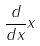<formula> <loc_0><loc_0><loc_500><loc_500>\frac { d } { d x } x</formula> 